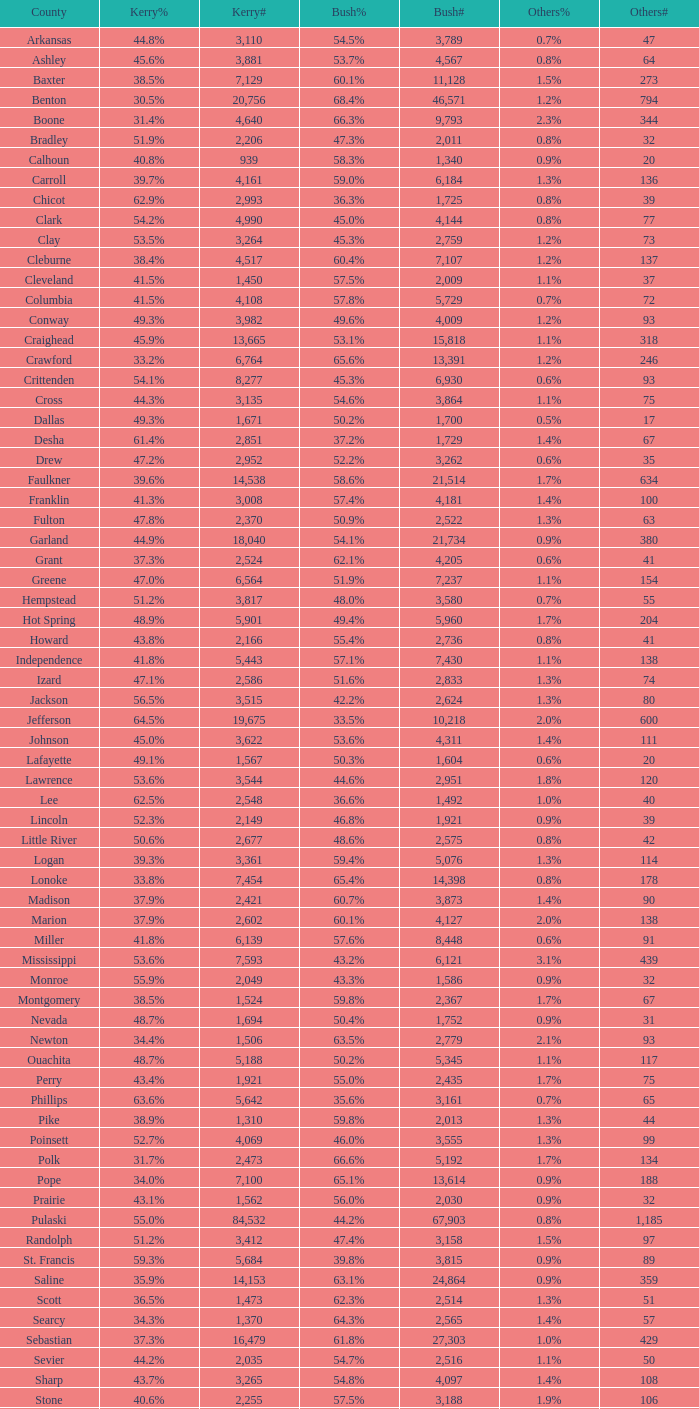4%"? 14398.0. 